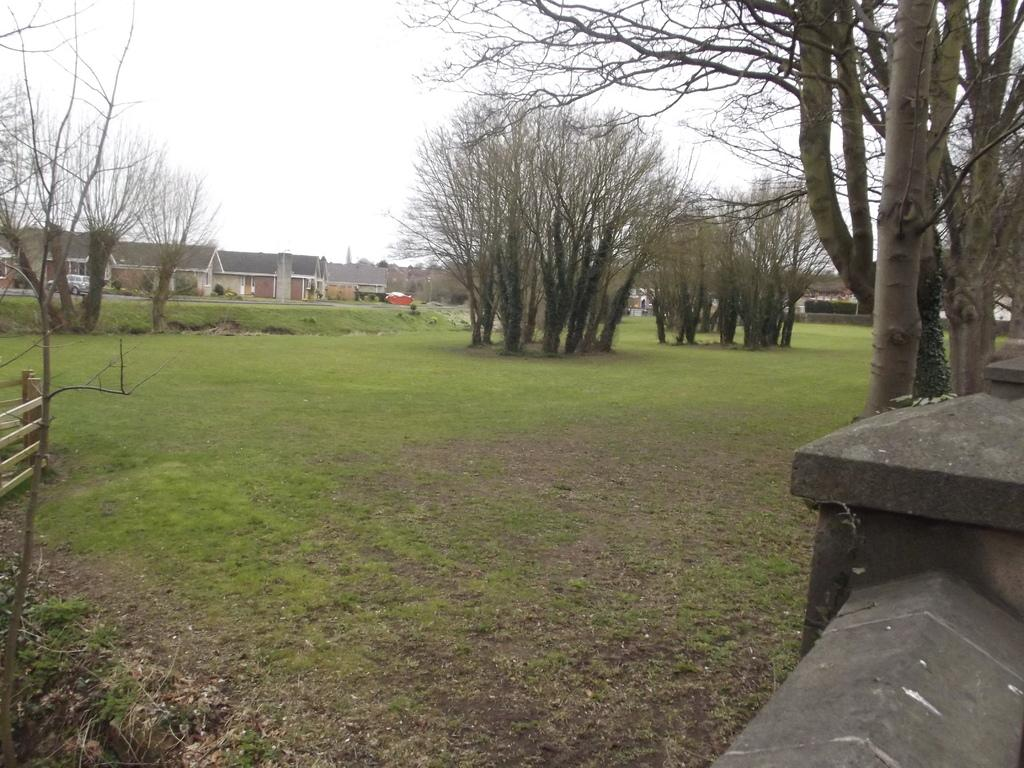What can be seen in the middle of the image? There are trees, houses, vehicles, and grass in the middle of the image. What is visible in the background of the image? There is sky visible in the image. What is located on the left side of the image? There is a fence on the left side of the image. What is located on the right side of the image? There are trees and a wall on the right side of the image. How many girls are sitting on the mountain in the image? There is no mountain or girls present in the image. What type of feeling is depicted in the image? The image does not depict any specific feeling; it shows trees, houses, vehicles, grass, sky, a fence, and a wall. 